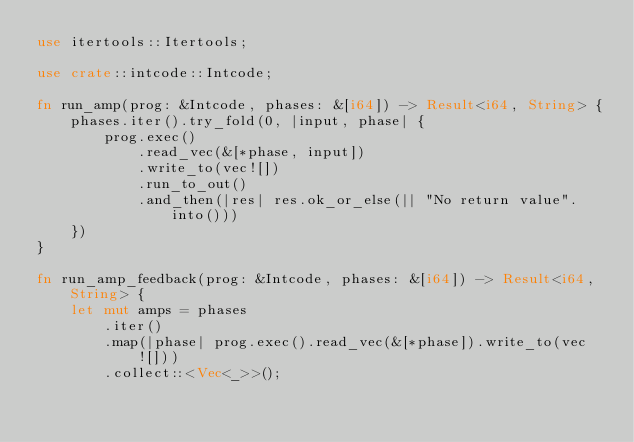<code> <loc_0><loc_0><loc_500><loc_500><_Rust_>use itertools::Itertools;

use crate::intcode::Intcode;

fn run_amp(prog: &Intcode, phases: &[i64]) -> Result<i64, String> {
    phases.iter().try_fold(0, |input, phase| {
        prog.exec()
            .read_vec(&[*phase, input])
            .write_to(vec![])
            .run_to_out()
            .and_then(|res| res.ok_or_else(|| "No return value".into()))
    })
}

fn run_amp_feedback(prog: &Intcode, phases: &[i64]) -> Result<i64, String> {
    let mut amps = phases
        .iter()
        .map(|phase| prog.exec().read_vec(&[*phase]).write_to(vec![]))
        .collect::<Vec<_>>();</code> 